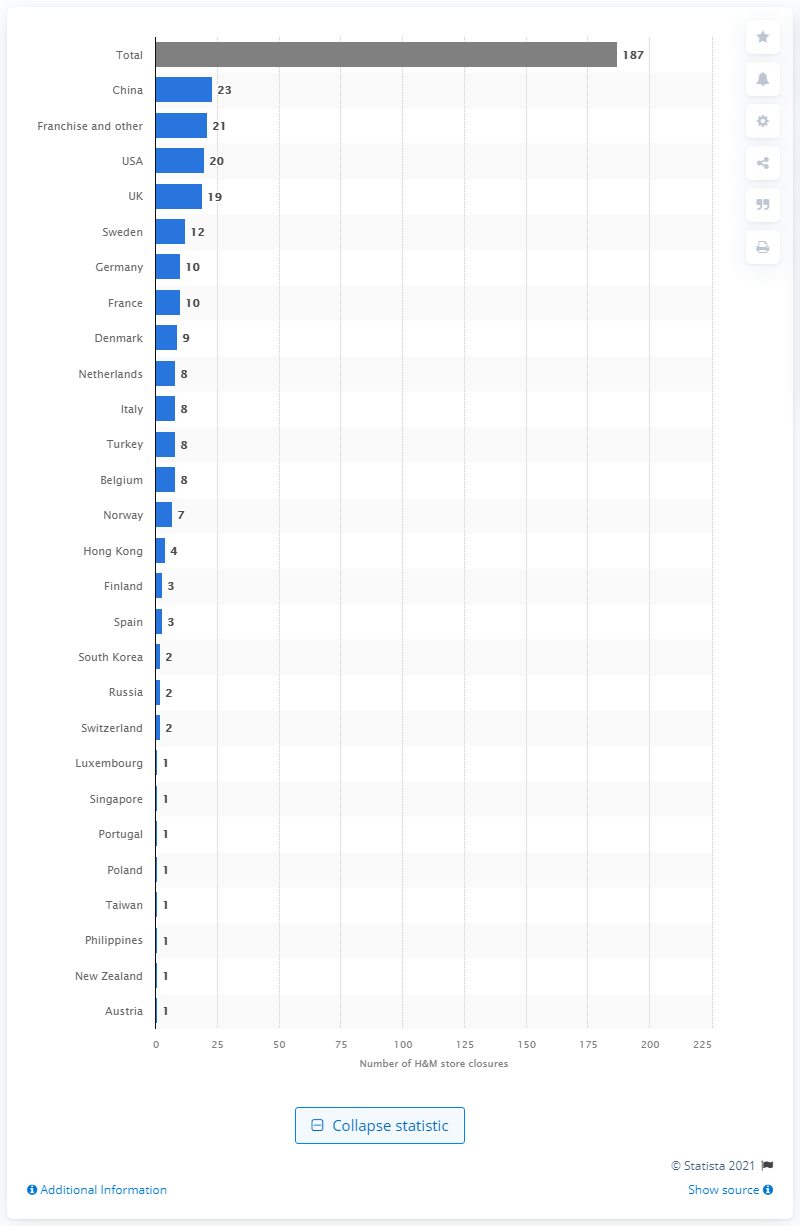Specify some key components in this picture. In 2020, a total of 20 H&M stores were closed in the United States. 